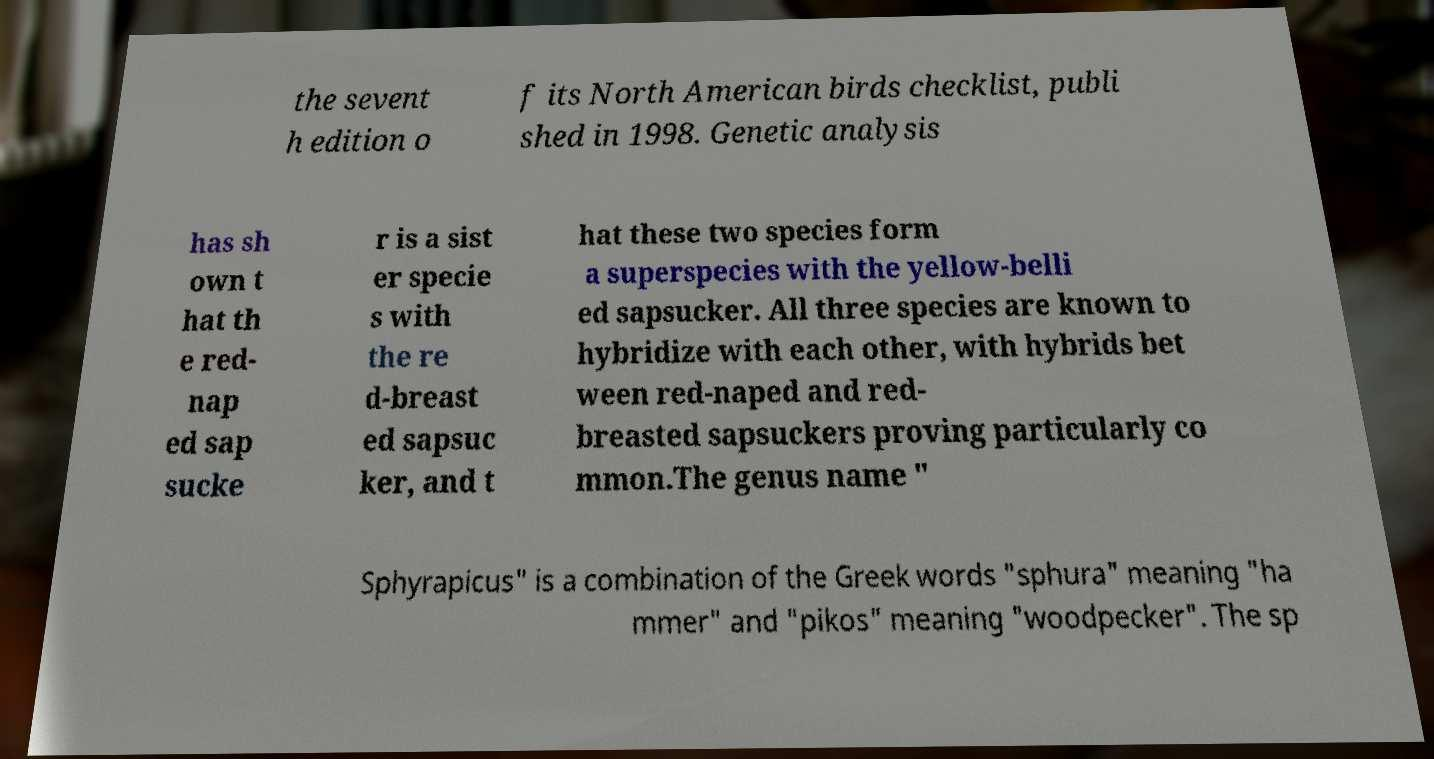Please identify and transcribe the text found in this image. the sevent h edition o f its North American birds checklist, publi shed in 1998. Genetic analysis has sh own t hat th e red- nap ed sap sucke r is a sist er specie s with the re d-breast ed sapsuc ker, and t hat these two species form a superspecies with the yellow-belli ed sapsucker. All three species are known to hybridize with each other, with hybrids bet ween red-naped and red- breasted sapsuckers proving particularly co mmon.The genus name " Sphyrapicus" is a combination of the Greek words "sphura" meaning "ha mmer" and "pikos" meaning "woodpecker". The sp 